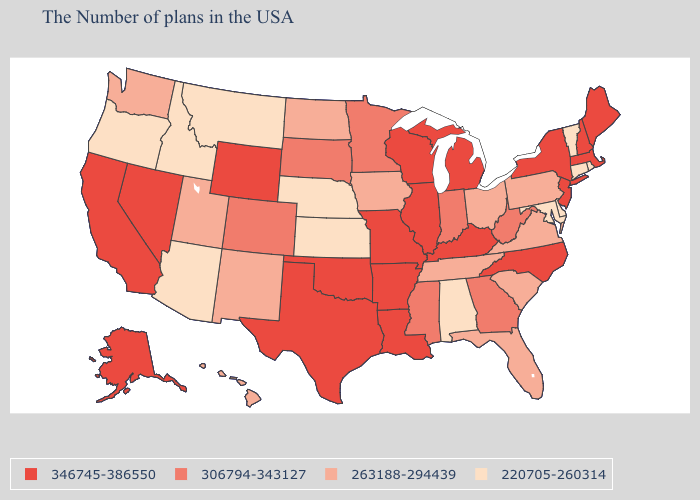Name the states that have a value in the range 263188-294439?
Give a very brief answer. Pennsylvania, Virginia, South Carolina, Ohio, Florida, Tennessee, Iowa, North Dakota, New Mexico, Utah, Washington, Hawaii. What is the lowest value in the South?
Be succinct. 220705-260314. Among the states that border Iowa , does Wisconsin have the lowest value?
Quick response, please. No. What is the value of Pennsylvania?
Keep it brief. 263188-294439. What is the value of South Dakota?
Quick response, please. 306794-343127. Among the states that border Delaware , does New Jersey have the highest value?
Concise answer only. Yes. What is the value of North Carolina?
Concise answer only. 346745-386550. Name the states that have a value in the range 263188-294439?
Write a very short answer. Pennsylvania, Virginia, South Carolina, Ohio, Florida, Tennessee, Iowa, North Dakota, New Mexico, Utah, Washington, Hawaii. Name the states that have a value in the range 346745-386550?
Write a very short answer. Maine, Massachusetts, New Hampshire, New York, New Jersey, North Carolina, Michigan, Kentucky, Wisconsin, Illinois, Louisiana, Missouri, Arkansas, Oklahoma, Texas, Wyoming, Nevada, California, Alaska. What is the value of Michigan?
Concise answer only. 346745-386550. What is the value of Nevada?
Keep it brief. 346745-386550. Name the states that have a value in the range 263188-294439?
Short answer required. Pennsylvania, Virginia, South Carolina, Ohio, Florida, Tennessee, Iowa, North Dakota, New Mexico, Utah, Washington, Hawaii. Among the states that border Maryland , which have the highest value?
Write a very short answer. West Virginia. Among the states that border North Dakota , does Minnesota have the highest value?
Write a very short answer. Yes. What is the highest value in states that border South Carolina?
Concise answer only. 346745-386550. 